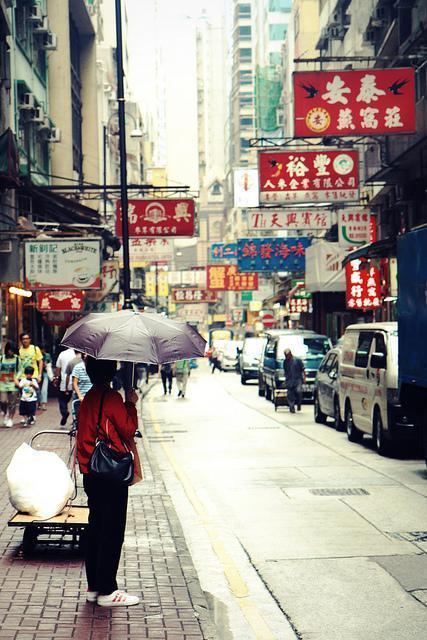How many cars are there?
Give a very brief answer. 2. How many boats are in the water?
Give a very brief answer. 0. 